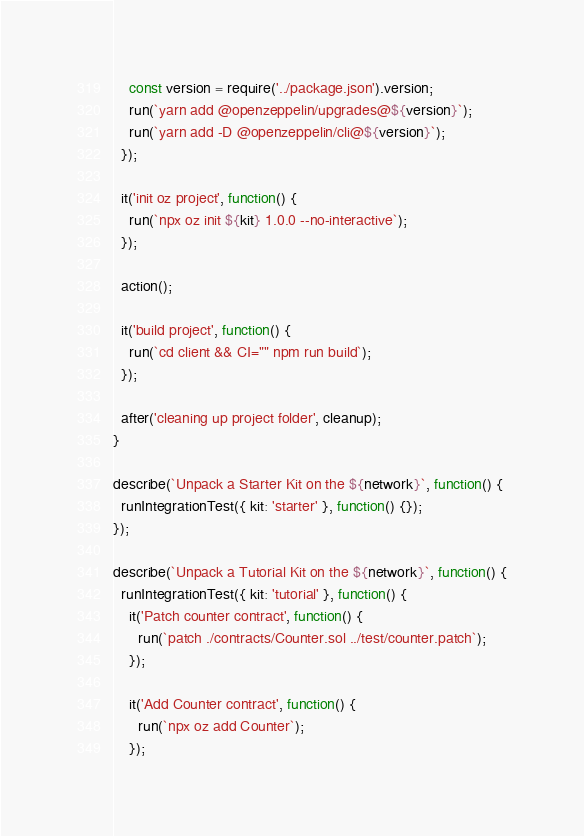Convert code to text. <code><loc_0><loc_0><loc_500><loc_500><_JavaScript_>    const version = require('../package.json').version;
    run(`yarn add @openzeppelin/upgrades@${version}`);
    run(`yarn add -D @openzeppelin/cli@${version}`);
  });

  it('init oz project', function() {
    run(`npx oz init ${kit} 1.0.0 --no-interactive`);
  });

  action();

  it('build project', function() {
    run(`cd client && CI="" npm run build`);
  });

  after('cleaning up project folder', cleanup);
}

describe(`Unpack a Starter Kit on the ${network}`, function() {
  runIntegrationTest({ kit: 'starter' }, function() {});
});

describe(`Unpack a Tutorial Kit on the ${network}`, function() {
  runIntegrationTest({ kit: 'tutorial' }, function() {
    it('Patch counter contract', function() {
      run(`patch ./contracts/Counter.sol ../test/counter.patch`);
    });

    it('Add Counter contract', function() {
      run(`npx oz add Counter`);
    });
</code> 